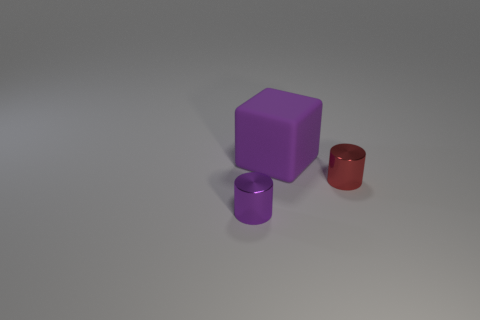Add 3 large yellow objects. How many objects exist? 6 Subtract all blocks. How many objects are left? 2 Add 1 small red shiny cylinders. How many small red shiny cylinders are left? 2 Add 2 purple cylinders. How many purple cylinders exist? 3 Subtract 0 green blocks. How many objects are left? 3 Subtract all large green blocks. Subtract all big purple rubber cubes. How many objects are left? 2 